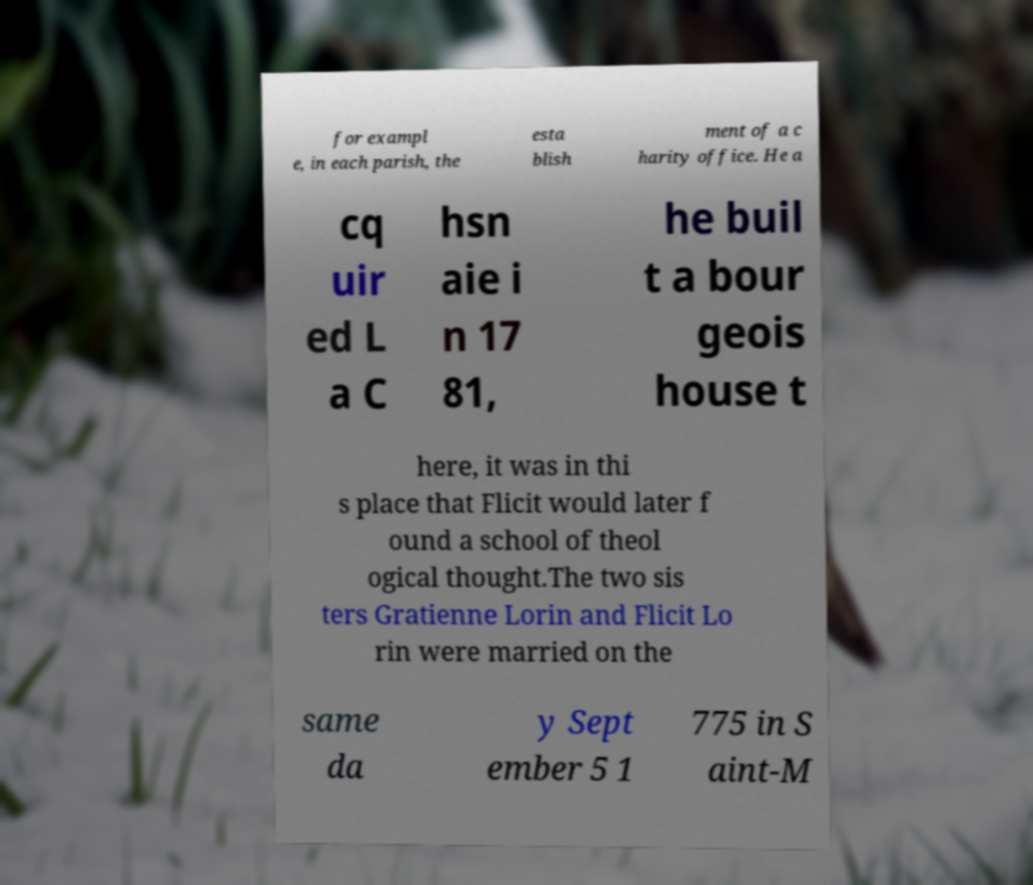Could you extract and type out the text from this image? for exampl e, in each parish, the esta blish ment of a c harity office. He a cq uir ed L a C hsn aie i n 17 81, he buil t a bour geois house t here, it was in thi s place that Flicit would later f ound a school of theol ogical thought.The two sis ters Gratienne Lorin and Flicit Lo rin were married on the same da y Sept ember 5 1 775 in S aint-M 